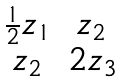<formula> <loc_0><loc_0><loc_500><loc_500>\begin{matrix} \frac { 1 } { 2 } z _ { 1 } & z _ { 2 } \\ z _ { 2 } & 2 z _ { 3 } \end{matrix}</formula> 